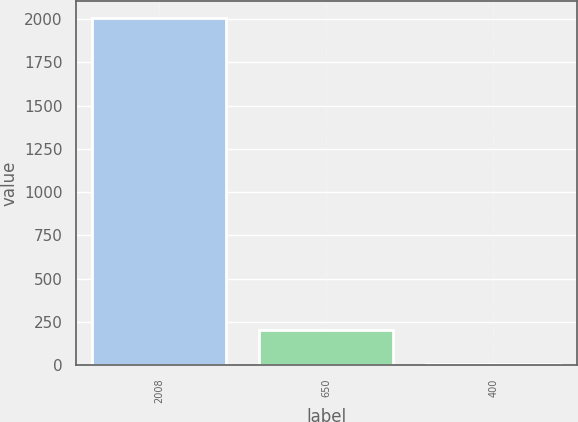Convert chart to OTSL. <chart><loc_0><loc_0><loc_500><loc_500><bar_chart><fcel>2008<fcel>650<fcel>400<nl><fcel>2007<fcel>205.11<fcel>4.9<nl></chart> 